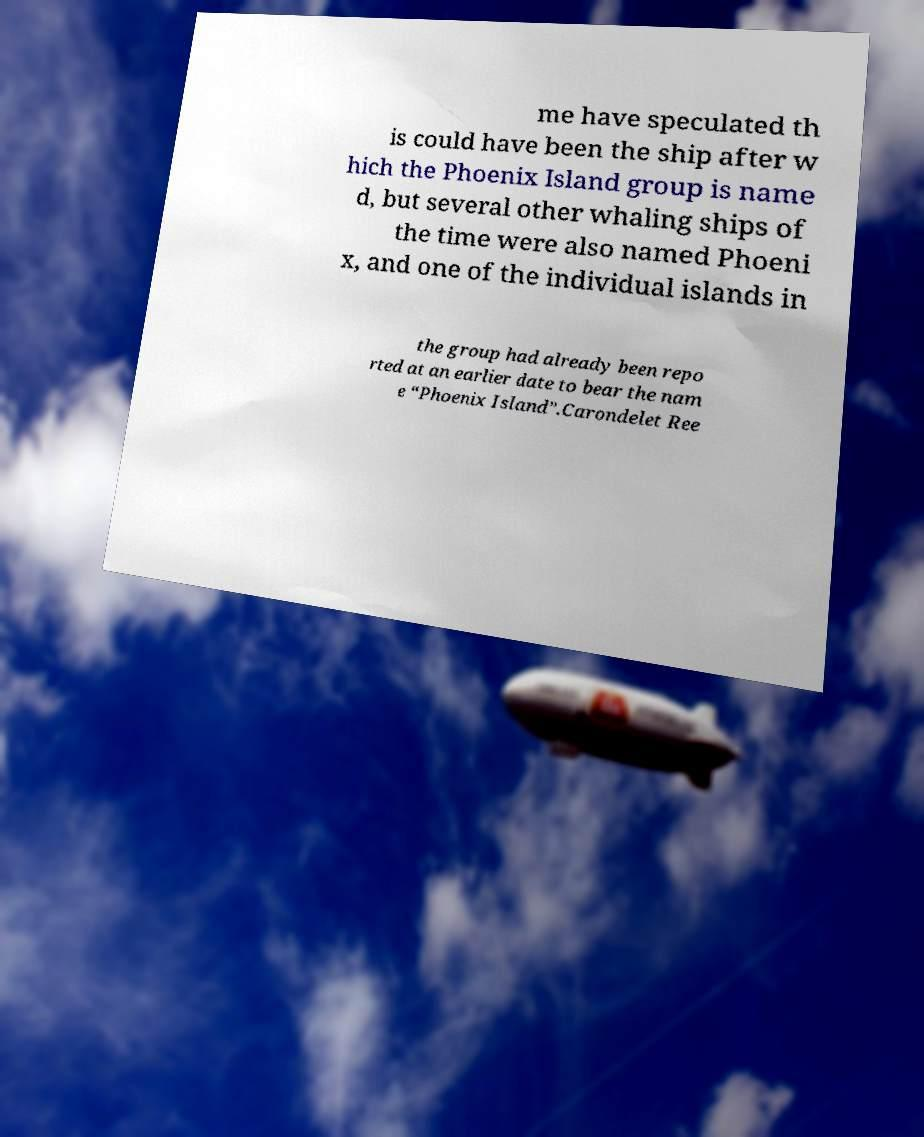For documentation purposes, I need the text within this image transcribed. Could you provide that? me have speculated th is could have been the ship after w hich the Phoenix Island group is name d, but several other whaling ships of the time were also named Phoeni x, and one of the individual islands in the group had already been repo rted at an earlier date to bear the nam e “Phoenix Island”.Carondelet Ree 